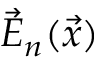Convert formula to latex. <formula><loc_0><loc_0><loc_500><loc_500>\vec { E } _ { n } ( \vec { x } )</formula> 